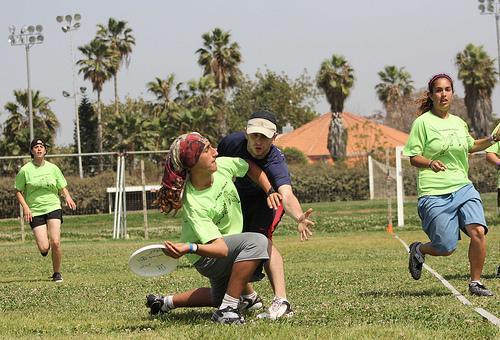How many people on the field?
Give a very brief answer. 4. How many people are wearing green shirts?
Give a very brief answer. 3. 